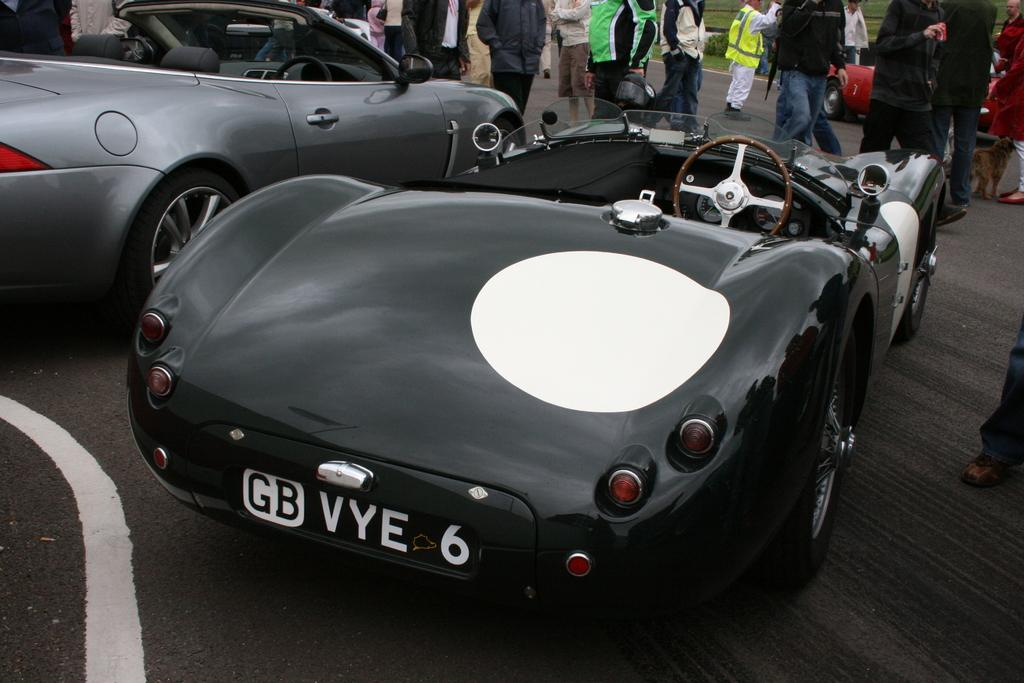How many cars are present in the image? There are two cars in the image. What else can be seen in the image besides the cars? There are people standing in the image. Are there any kites visible in the image? No, there are no kites present in the image. How many balls can be seen in the image? There are no balls visible in the image. 